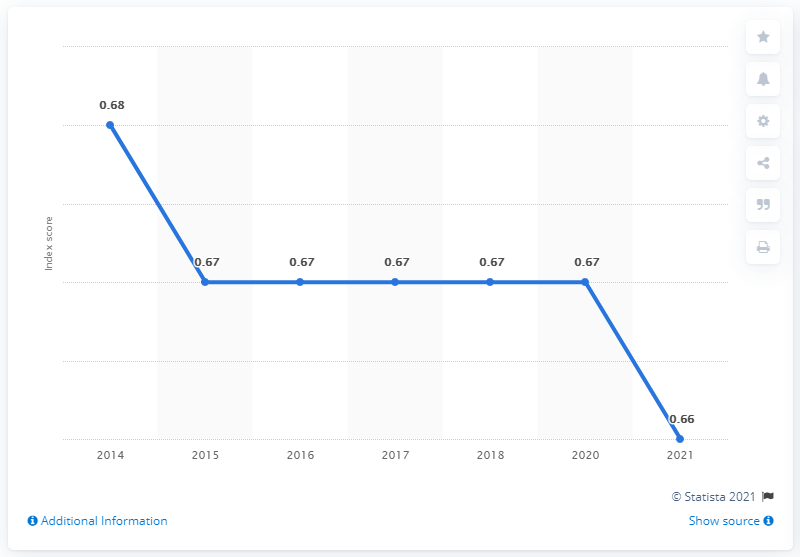Specify some key components in this picture. In 2021, Guatemala's gender gap index score was 0.66, indicating a moderate level of gender equality in the country. 